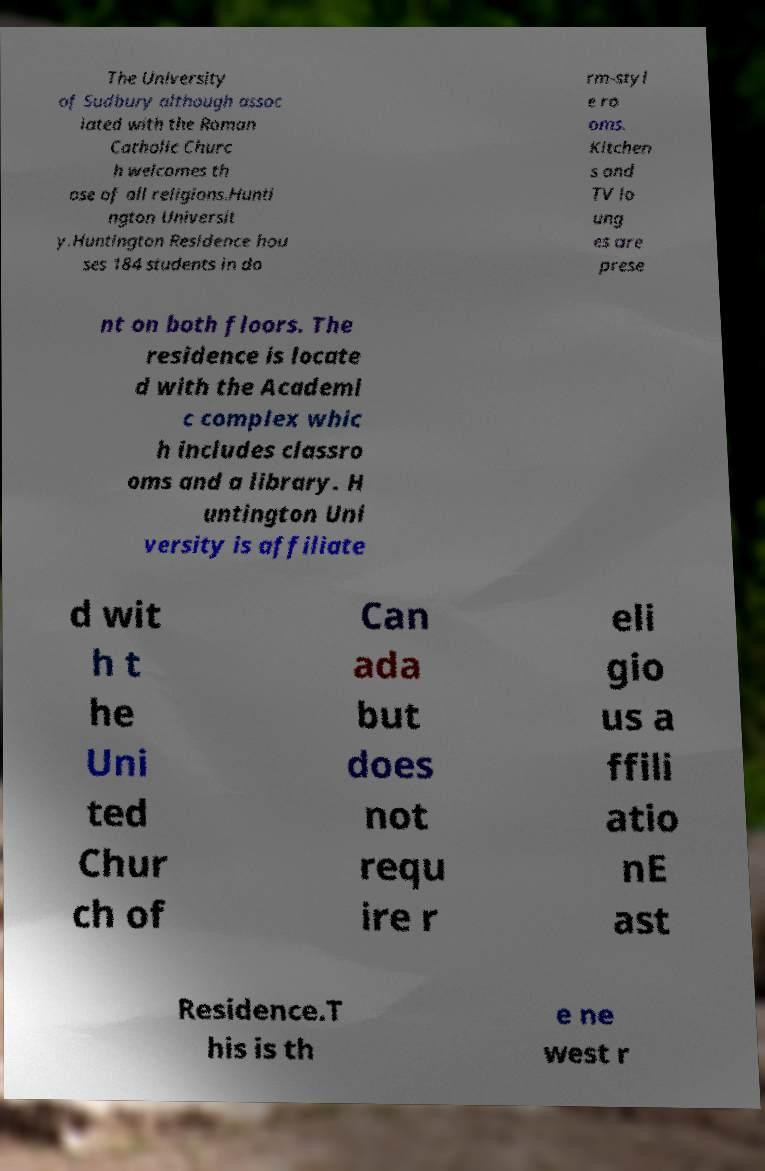What messages or text are displayed in this image? I need them in a readable, typed format. The University of Sudbury although assoc iated with the Roman Catholic Churc h welcomes th ose of all religions.Hunti ngton Universit y.Huntington Residence hou ses 184 students in do rm-styl e ro oms. Kitchen s and TV lo ung es are prese nt on both floors. The residence is locate d with the Academi c complex whic h includes classro oms and a library. H untington Uni versity is affiliate d wit h t he Uni ted Chur ch of Can ada but does not requ ire r eli gio us a ffili atio nE ast Residence.T his is th e ne west r 